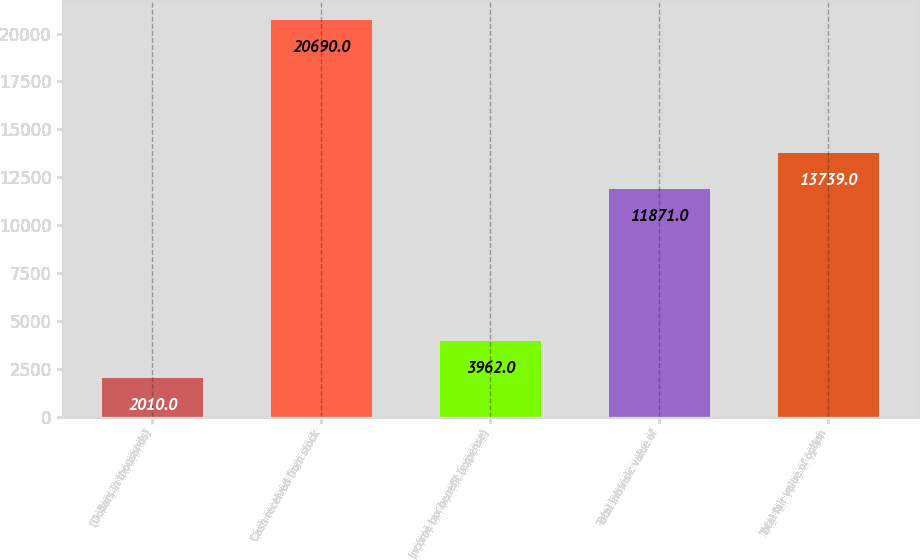<chart> <loc_0><loc_0><loc_500><loc_500><bar_chart><fcel>(Dollars in thousands)<fcel>Cash received from stock<fcel>Income tax benefit (expense)<fcel>Total intrinsic value of<fcel>Total fair value of option<nl><fcel>2010<fcel>20690<fcel>3962<fcel>11871<fcel>13739<nl></chart> 